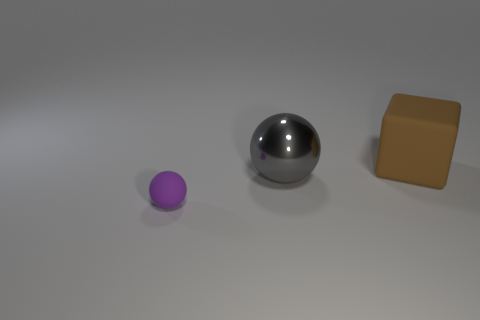Add 1 large gray metal things. How many objects exist? 4 Subtract all big yellow rubber cylinders. Subtract all purple balls. How many objects are left? 2 Add 3 tiny rubber things. How many tiny rubber things are left? 4 Add 1 large yellow rubber cylinders. How many large yellow rubber cylinders exist? 1 Subtract 0 cyan spheres. How many objects are left? 3 Subtract all cubes. How many objects are left? 2 Subtract all purple balls. Subtract all red cylinders. How many balls are left? 1 Subtract all gray cubes. How many green balls are left? 0 